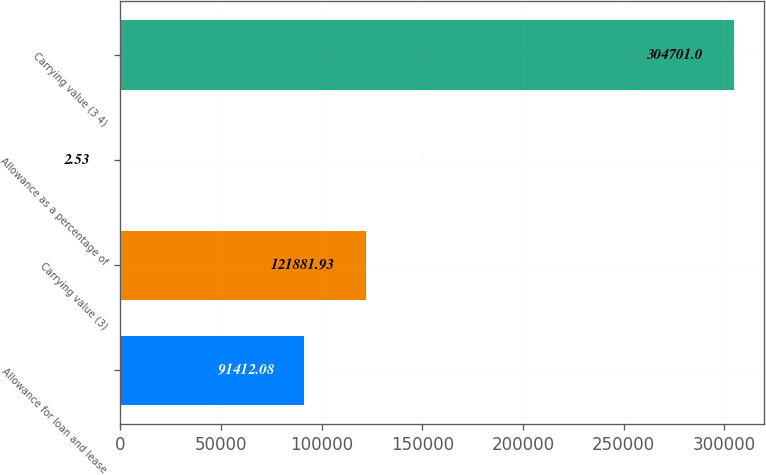Convert chart. <chart><loc_0><loc_0><loc_500><loc_500><bar_chart><fcel>Allowance for loan and lease<fcel>Carrying value (3)<fcel>Allowance as a percentage of<fcel>Carrying value (3 4)<nl><fcel>91412.1<fcel>121882<fcel>2.53<fcel>304701<nl></chart> 